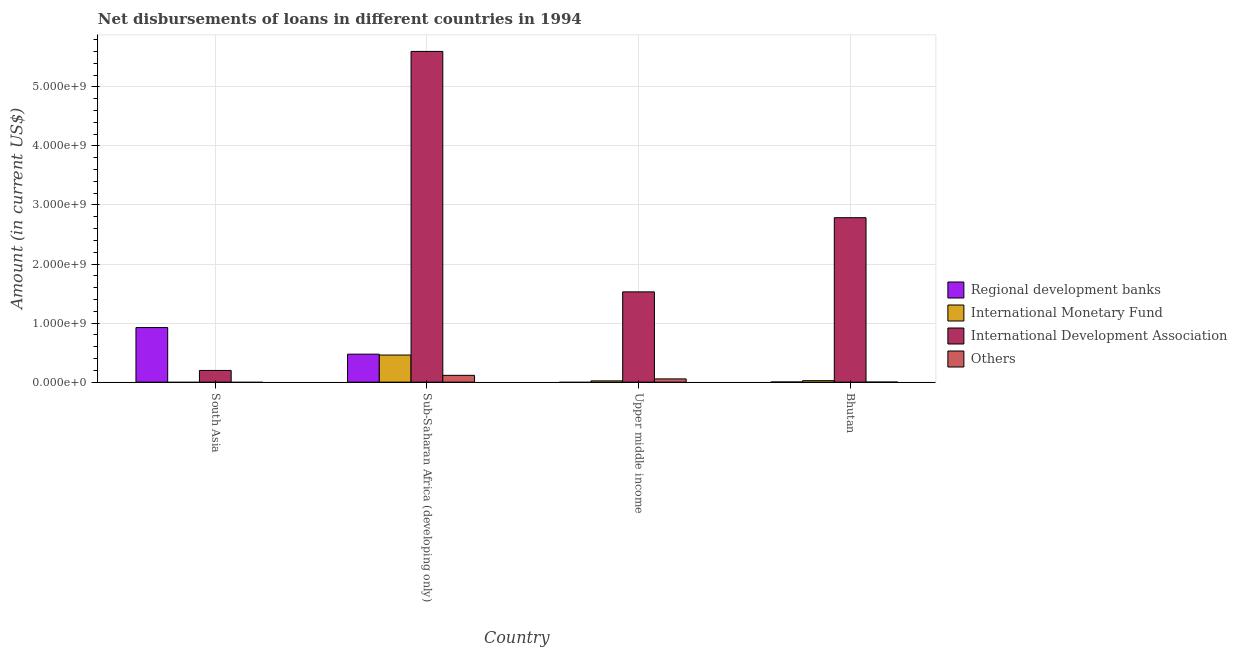How many groups of bars are there?
Make the answer very short. 4. How many bars are there on the 3rd tick from the left?
Provide a short and direct response. 3. How many bars are there on the 3rd tick from the right?
Make the answer very short. 4. What is the label of the 3rd group of bars from the left?
Your answer should be compact. Upper middle income. In how many cases, is the number of bars for a given country not equal to the number of legend labels?
Your response must be concise. 2. What is the amount of loan disimbursed by other organisations in Bhutan?
Give a very brief answer. 6.26e+05. Across all countries, what is the maximum amount of loan disimbursed by other organisations?
Give a very brief answer. 1.15e+08. Across all countries, what is the minimum amount of loan disimbursed by other organisations?
Offer a terse response. 0. In which country was the amount of loan disimbursed by other organisations maximum?
Make the answer very short. Sub-Saharan Africa (developing only). What is the total amount of loan disimbursed by regional development banks in the graph?
Make the answer very short. 1.40e+09. What is the difference between the amount of loan disimbursed by international monetary fund in Bhutan and that in Sub-Saharan Africa (developing only)?
Your response must be concise. -4.34e+08. What is the difference between the amount of loan disimbursed by other organisations in Upper middle income and the amount of loan disimbursed by international development association in Bhutan?
Provide a succinct answer. -2.73e+09. What is the average amount of loan disimbursed by international monetary fund per country?
Make the answer very short. 1.26e+08. What is the difference between the amount of loan disimbursed by international development association and amount of loan disimbursed by regional development banks in Bhutan?
Make the answer very short. 2.78e+09. In how many countries, is the amount of loan disimbursed by regional development banks greater than 200000000 US$?
Your answer should be very brief. 2. What is the ratio of the amount of loan disimbursed by international development association in Bhutan to that in Upper middle income?
Give a very brief answer. 1.82. What is the difference between the highest and the second highest amount of loan disimbursed by regional development banks?
Offer a very short reply. 4.51e+08. What is the difference between the highest and the lowest amount of loan disimbursed by international monetary fund?
Your answer should be compact. 4.59e+08. In how many countries, is the amount of loan disimbursed by regional development banks greater than the average amount of loan disimbursed by regional development banks taken over all countries?
Your answer should be very brief. 2. Is the sum of the amount of loan disimbursed by international development association in Bhutan and South Asia greater than the maximum amount of loan disimbursed by regional development banks across all countries?
Your response must be concise. Yes. Is it the case that in every country, the sum of the amount of loan disimbursed by regional development banks and amount of loan disimbursed by international monetary fund is greater than the amount of loan disimbursed by international development association?
Provide a succinct answer. No. How many bars are there?
Your answer should be very brief. 13. What is the difference between two consecutive major ticks on the Y-axis?
Provide a short and direct response. 1.00e+09. Are the values on the major ticks of Y-axis written in scientific E-notation?
Your response must be concise. Yes. How many legend labels are there?
Keep it short and to the point. 4. How are the legend labels stacked?
Make the answer very short. Vertical. What is the title of the graph?
Make the answer very short. Net disbursements of loans in different countries in 1994. What is the label or title of the X-axis?
Offer a very short reply. Country. What is the Amount (in current US$) of Regional development banks in South Asia?
Give a very brief answer. 9.24e+08. What is the Amount (in current US$) in International Monetary Fund in South Asia?
Offer a terse response. 0. What is the Amount (in current US$) in International Development Association in South Asia?
Offer a very short reply. 1.98e+08. What is the Amount (in current US$) of Others in South Asia?
Ensure brevity in your answer.  0. What is the Amount (in current US$) of Regional development banks in Sub-Saharan Africa (developing only)?
Provide a succinct answer. 4.74e+08. What is the Amount (in current US$) of International Monetary Fund in Sub-Saharan Africa (developing only)?
Keep it short and to the point. 4.59e+08. What is the Amount (in current US$) in International Development Association in Sub-Saharan Africa (developing only)?
Provide a succinct answer. 5.60e+09. What is the Amount (in current US$) in Others in Sub-Saharan Africa (developing only)?
Ensure brevity in your answer.  1.15e+08. What is the Amount (in current US$) in Regional development banks in Upper middle income?
Your answer should be compact. 0. What is the Amount (in current US$) of International Monetary Fund in Upper middle income?
Offer a terse response. 2.15e+07. What is the Amount (in current US$) of International Development Association in Upper middle income?
Keep it short and to the point. 1.53e+09. What is the Amount (in current US$) of Others in Upper middle income?
Offer a very short reply. 5.51e+07. What is the Amount (in current US$) of Regional development banks in Bhutan?
Keep it short and to the point. 2.29e+06. What is the Amount (in current US$) in International Monetary Fund in Bhutan?
Make the answer very short. 2.51e+07. What is the Amount (in current US$) in International Development Association in Bhutan?
Offer a very short reply. 2.78e+09. What is the Amount (in current US$) in Others in Bhutan?
Make the answer very short. 6.26e+05. Across all countries, what is the maximum Amount (in current US$) in Regional development banks?
Your answer should be compact. 9.24e+08. Across all countries, what is the maximum Amount (in current US$) of International Monetary Fund?
Your response must be concise. 4.59e+08. Across all countries, what is the maximum Amount (in current US$) of International Development Association?
Offer a very short reply. 5.60e+09. Across all countries, what is the maximum Amount (in current US$) of Others?
Offer a very short reply. 1.15e+08. Across all countries, what is the minimum Amount (in current US$) in Regional development banks?
Ensure brevity in your answer.  0. Across all countries, what is the minimum Amount (in current US$) in International Development Association?
Give a very brief answer. 1.98e+08. Across all countries, what is the minimum Amount (in current US$) of Others?
Offer a terse response. 0. What is the total Amount (in current US$) of Regional development banks in the graph?
Offer a very short reply. 1.40e+09. What is the total Amount (in current US$) of International Monetary Fund in the graph?
Your answer should be compact. 5.05e+08. What is the total Amount (in current US$) of International Development Association in the graph?
Give a very brief answer. 1.01e+1. What is the total Amount (in current US$) in Others in the graph?
Provide a short and direct response. 1.71e+08. What is the difference between the Amount (in current US$) in Regional development banks in South Asia and that in Sub-Saharan Africa (developing only)?
Ensure brevity in your answer.  4.51e+08. What is the difference between the Amount (in current US$) in International Development Association in South Asia and that in Sub-Saharan Africa (developing only)?
Offer a very short reply. -5.40e+09. What is the difference between the Amount (in current US$) in International Development Association in South Asia and that in Upper middle income?
Offer a terse response. -1.33e+09. What is the difference between the Amount (in current US$) in Regional development banks in South Asia and that in Bhutan?
Ensure brevity in your answer.  9.22e+08. What is the difference between the Amount (in current US$) of International Development Association in South Asia and that in Bhutan?
Keep it short and to the point. -2.59e+09. What is the difference between the Amount (in current US$) of International Monetary Fund in Sub-Saharan Africa (developing only) and that in Upper middle income?
Your answer should be compact. 4.37e+08. What is the difference between the Amount (in current US$) of International Development Association in Sub-Saharan Africa (developing only) and that in Upper middle income?
Offer a very short reply. 4.07e+09. What is the difference between the Amount (in current US$) of Others in Sub-Saharan Africa (developing only) and that in Upper middle income?
Offer a very short reply. 6.01e+07. What is the difference between the Amount (in current US$) in Regional development banks in Sub-Saharan Africa (developing only) and that in Bhutan?
Your response must be concise. 4.71e+08. What is the difference between the Amount (in current US$) of International Monetary Fund in Sub-Saharan Africa (developing only) and that in Bhutan?
Provide a succinct answer. 4.34e+08. What is the difference between the Amount (in current US$) of International Development Association in Sub-Saharan Africa (developing only) and that in Bhutan?
Your response must be concise. 2.82e+09. What is the difference between the Amount (in current US$) in Others in Sub-Saharan Africa (developing only) and that in Bhutan?
Make the answer very short. 1.15e+08. What is the difference between the Amount (in current US$) of International Monetary Fund in Upper middle income and that in Bhutan?
Provide a short and direct response. -3.58e+06. What is the difference between the Amount (in current US$) in International Development Association in Upper middle income and that in Bhutan?
Offer a terse response. -1.26e+09. What is the difference between the Amount (in current US$) in Others in Upper middle income and that in Bhutan?
Your answer should be compact. 5.45e+07. What is the difference between the Amount (in current US$) of Regional development banks in South Asia and the Amount (in current US$) of International Monetary Fund in Sub-Saharan Africa (developing only)?
Offer a very short reply. 4.66e+08. What is the difference between the Amount (in current US$) of Regional development banks in South Asia and the Amount (in current US$) of International Development Association in Sub-Saharan Africa (developing only)?
Your answer should be very brief. -4.68e+09. What is the difference between the Amount (in current US$) in Regional development banks in South Asia and the Amount (in current US$) in Others in Sub-Saharan Africa (developing only)?
Ensure brevity in your answer.  8.09e+08. What is the difference between the Amount (in current US$) in International Development Association in South Asia and the Amount (in current US$) in Others in Sub-Saharan Africa (developing only)?
Provide a short and direct response. 8.29e+07. What is the difference between the Amount (in current US$) in Regional development banks in South Asia and the Amount (in current US$) in International Monetary Fund in Upper middle income?
Your response must be concise. 9.03e+08. What is the difference between the Amount (in current US$) in Regional development banks in South Asia and the Amount (in current US$) in International Development Association in Upper middle income?
Your response must be concise. -6.04e+08. What is the difference between the Amount (in current US$) of Regional development banks in South Asia and the Amount (in current US$) of Others in Upper middle income?
Keep it short and to the point. 8.69e+08. What is the difference between the Amount (in current US$) of International Development Association in South Asia and the Amount (in current US$) of Others in Upper middle income?
Your answer should be very brief. 1.43e+08. What is the difference between the Amount (in current US$) in Regional development banks in South Asia and the Amount (in current US$) in International Monetary Fund in Bhutan?
Your answer should be compact. 8.99e+08. What is the difference between the Amount (in current US$) of Regional development banks in South Asia and the Amount (in current US$) of International Development Association in Bhutan?
Give a very brief answer. -1.86e+09. What is the difference between the Amount (in current US$) of Regional development banks in South Asia and the Amount (in current US$) of Others in Bhutan?
Your answer should be very brief. 9.24e+08. What is the difference between the Amount (in current US$) of International Development Association in South Asia and the Amount (in current US$) of Others in Bhutan?
Keep it short and to the point. 1.98e+08. What is the difference between the Amount (in current US$) in Regional development banks in Sub-Saharan Africa (developing only) and the Amount (in current US$) in International Monetary Fund in Upper middle income?
Keep it short and to the point. 4.52e+08. What is the difference between the Amount (in current US$) of Regional development banks in Sub-Saharan Africa (developing only) and the Amount (in current US$) of International Development Association in Upper middle income?
Keep it short and to the point. -1.05e+09. What is the difference between the Amount (in current US$) of Regional development banks in Sub-Saharan Africa (developing only) and the Amount (in current US$) of Others in Upper middle income?
Provide a short and direct response. 4.19e+08. What is the difference between the Amount (in current US$) of International Monetary Fund in Sub-Saharan Africa (developing only) and the Amount (in current US$) of International Development Association in Upper middle income?
Provide a succinct answer. -1.07e+09. What is the difference between the Amount (in current US$) in International Monetary Fund in Sub-Saharan Africa (developing only) and the Amount (in current US$) in Others in Upper middle income?
Provide a succinct answer. 4.04e+08. What is the difference between the Amount (in current US$) in International Development Association in Sub-Saharan Africa (developing only) and the Amount (in current US$) in Others in Upper middle income?
Keep it short and to the point. 5.54e+09. What is the difference between the Amount (in current US$) in Regional development banks in Sub-Saharan Africa (developing only) and the Amount (in current US$) in International Monetary Fund in Bhutan?
Give a very brief answer. 4.49e+08. What is the difference between the Amount (in current US$) in Regional development banks in Sub-Saharan Africa (developing only) and the Amount (in current US$) in International Development Association in Bhutan?
Make the answer very short. -2.31e+09. What is the difference between the Amount (in current US$) in Regional development banks in Sub-Saharan Africa (developing only) and the Amount (in current US$) in Others in Bhutan?
Your answer should be very brief. 4.73e+08. What is the difference between the Amount (in current US$) in International Monetary Fund in Sub-Saharan Africa (developing only) and the Amount (in current US$) in International Development Association in Bhutan?
Your response must be concise. -2.33e+09. What is the difference between the Amount (in current US$) in International Monetary Fund in Sub-Saharan Africa (developing only) and the Amount (in current US$) in Others in Bhutan?
Your response must be concise. 4.58e+08. What is the difference between the Amount (in current US$) in International Development Association in Sub-Saharan Africa (developing only) and the Amount (in current US$) in Others in Bhutan?
Your answer should be very brief. 5.60e+09. What is the difference between the Amount (in current US$) in International Monetary Fund in Upper middle income and the Amount (in current US$) in International Development Association in Bhutan?
Make the answer very short. -2.76e+09. What is the difference between the Amount (in current US$) of International Monetary Fund in Upper middle income and the Amount (in current US$) of Others in Bhutan?
Your answer should be very brief. 2.08e+07. What is the difference between the Amount (in current US$) in International Development Association in Upper middle income and the Amount (in current US$) in Others in Bhutan?
Ensure brevity in your answer.  1.53e+09. What is the average Amount (in current US$) of Regional development banks per country?
Your answer should be compact. 3.50e+08. What is the average Amount (in current US$) of International Monetary Fund per country?
Provide a short and direct response. 1.26e+08. What is the average Amount (in current US$) of International Development Association per country?
Ensure brevity in your answer.  2.53e+09. What is the average Amount (in current US$) in Others per country?
Your answer should be compact. 4.27e+07. What is the difference between the Amount (in current US$) in Regional development banks and Amount (in current US$) in International Development Association in South Asia?
Provide a succinct answer. 7.26e+08. What is the difference between the Amount (in current US$) of Regional development banks and Amount (in current US$) of International Monetary Fund in Sub-Saharan Africa (developing only)?
Your answer should be very brief. 1.48e+07. What is the difference between the Amount (in current US$) in Regional development banks and Amount (in current US$) in International Development Association in Sub-Saharan Africa (developing only)?
Keep it short and to the point. -5.13e+09. What is the difference between the Amount (in current US$) of Regional development banks and Amount (in current US$) of Others in Sub-Saharan Africa (developing only)?
Your answer should be very brief. 3.58e+08. What is the difference between the Amount (in current US$) of International Monetary Fund and Amount (in current US$) of International Development Association in Sub-Saharan Africa (developing only)?
Provide a short and direct response. -5.14e+09. What is the difference between the Amount (in current US$) of International Monetary Fund and Amount (in current US$) of Others in Sub-Saharan Africa (developing only)?
Your answer should be compact. 3.44e+08. What is the difference between the Amount (in current US$) of International Development Association and Amount (in current US$) of Others in Sub-Saharan Africa (developing only)?
Your answer should be very brief. 5.48e+09. What is the difference between the Amount (in current US$) in International Monetary Fund and Amount (in current US$) in International Development Association in Upper middle income?
Provide a short and direct response. -1.51e+09. What is the difference between the Amount (in current US$) in International Monetary Fund and Amount (in current US$) in Others in Upper middle income?
Give a very brief answer. -3.36e+07. What is the difference between the Amount (in current US$) in International Development Association and Amount (in current US$) in Others in Upper middle income?
Your answer should be very brief. 1.47e+09. What is the difference between the Amount (in current US$) in Regional development banks and Amount (in current US$) in International Monetary Fund in Bhutan?
Provide a succinct answer. -2.28e+07. What is the difference between the Amount (in current US$) of Regional development banks and Amount (in current US$) of International Development Association in Bhutan?
Your answer should be compact. -2.78e+09. What is the difference between the Amount (in current US$) in Regional development banks and Amount (in current US$) in Others in Bhutan?
Your answer should be compact. 1.66e+06. What is the difference between the Amount (in current US$) in International Monetary Fund and Amount (in current US$) in International Development Association in Bhutan?
Offer a very short reply. -2.76e+09. What is the difference between the Amount (in current US$) of International Monetary Fund and Amount (in current US$) of Others in Bhutan?
Ensure brevity in your answer.  2.44e+07. What is the difference between the Amount (in current US$) of International Development Association and Amount (in current US$) of Others in Bhutan?
Give a very brief answer. 2.78e+09. What is the ratio of the Amount (in current US$) in Regional development banks in South Asia to that in Sub-Saharan Africa (developing only)?
Provide a succinct answer. 1.95. What is the ratio of the Amount (in current US$) of International Development Association in South Asia to that in Sub-Saharan Africa (developing only)?
Offer a terse response. 0.04. What is the ratio of the Amount (in current US$) of International Development Association in South Asia to that in Upper middle income?
Offer a terse response. 0.13. What is the ratio of the Amount (in current US$) in Regional development banks in South Asia to that in Bhutan?
Ensure brevity in your answer.  404.38. What is the ratio of the Amount (in current US$) of International Development Association in South Asia to that in Bhutan?
Give a very brief answer. 0.07. What is the ratio of the Amount (in current US$) of International Monetary Fund in Sub-Saharan Africa (developing only) to that in Upper middle income?
Provide a short and direct response. 21.37. What is the ratio of the Amount (in current US$) of International Development Association in Sub-Saharan Africa (developing only) to that in Upper middle income?
Give a very brief answer. 3.66. What is the ratio of the Amount (in current US$) in Others in Sub-Saharan Africa (developing only) to that in Upper middle income?
Provide a short and direct response. 2.09. What is the ratio of the Amount (in current US$) in Regional development banks in Sub-Saharan Africa (developing only) to that in Bhutan?
Your answer should be compact. 207.22. What is the ratio of the Amount (in current US$) of International Monetary Fund in Sub-Saharan Africa (developing only) to that in Bhutan?
Offer a terse response. 18.32. What is the ratio of the Amount (in current US$) of International Development Association in Sub-Saharan Africa (developing only) to that in Bhutan?
Offer a very short reply. 2.01. What is the ratio of the Amount (in current US$) in Others in Sub-Saharan Africa (developing only) to that in Bhutan?
Give a very brief answer. 184.06. What is the ratio of the Amount (in current US$) of International Monetary Fund in Upper middle income to that in Bhutan?
Ensure brevity in your answer.  0.86. What is the ratio of the Amount (in current US$) of International Development Association in Upper middle income to that in Bhutan?
Your answer should be very brief. 0.55. What is the ratio of the Amount (in current US$) of Others in Upper middle income to that in Bhutan?
Keep it short and to the point. 88.03. What is the difference between the highest and the second highest Amount (in current US$) in Regional development banks?
Your answer should be compact. 4.51e+08. What is the difference between the highest and the second highest Amount (in current US$) of International Monetary Fund?
Offer a terse response. 4.34e+08. What is the difference between the highest and the second highest Amount (in current US$) in International Development Association?
Your answer should be compact. 2.82e+09. What is the difference between the highest and the second highest Amount (in current US$) of Others?
Provide a succinct answer. 6.01e+07. What is the difference between the highest and the lowest Amount (in current US$) in Regional development banks?
Keep it short and to the point. 9.24e+08. What is the difference between the highest and the lowest Amount (in current US$) in International Monetary Fund?
Your response must be concise. 4.59e+08. What is the difference between the highest and the lowest Amount (in current US$) in International Development Association?
Your answer should be compact. 5.40e+09. What is the difference between the highest and the lowest Amount (in current US$) in Others?
Offer a terse response. 1.15e+08. 